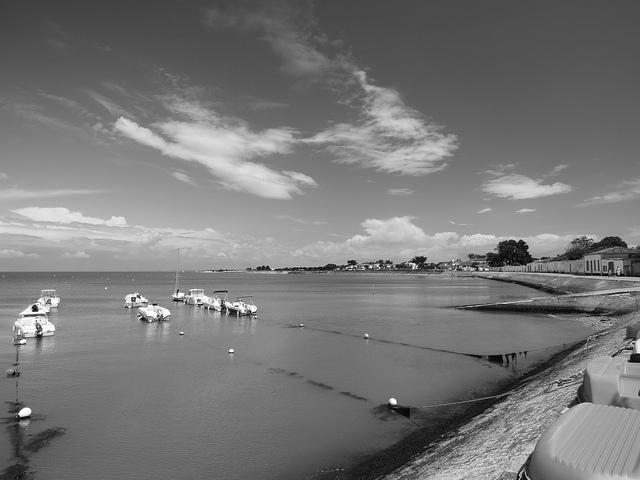What vehicles are located in the water?

Choices:
A) yacht
B) boat
C) canoe
D) jet ski boat 